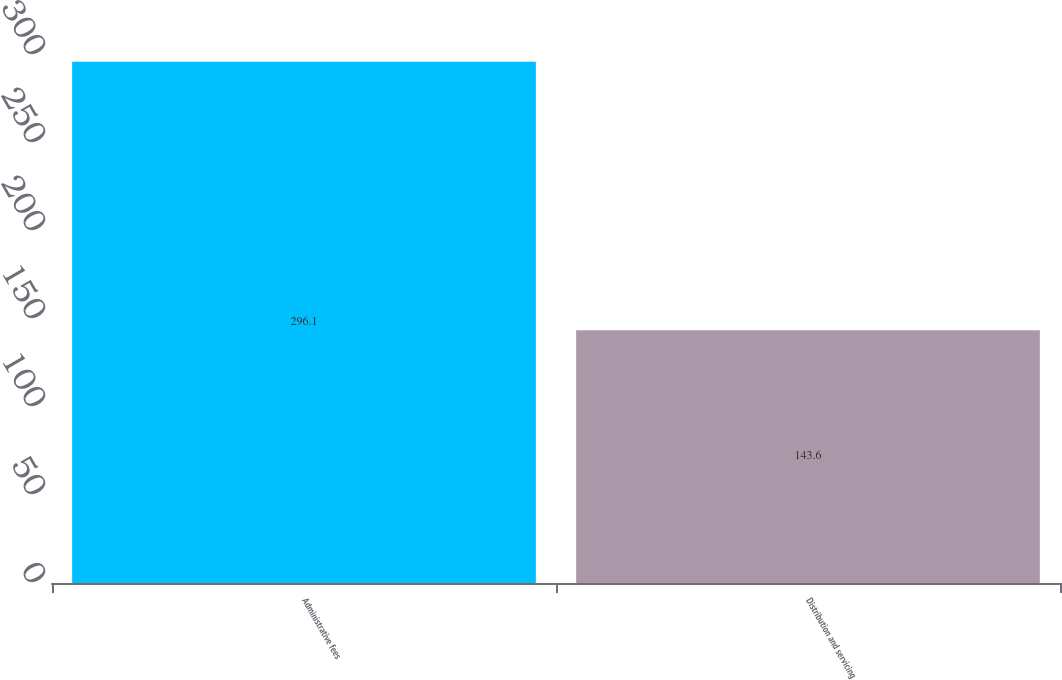<chart> <loc_0><loc_0><loc_500><loc_500><bar_chart><fcel>Administrative fees<fcel>Distribution and servicing<nl><fcel>296.1<fcel>143.6<nl></chart> 